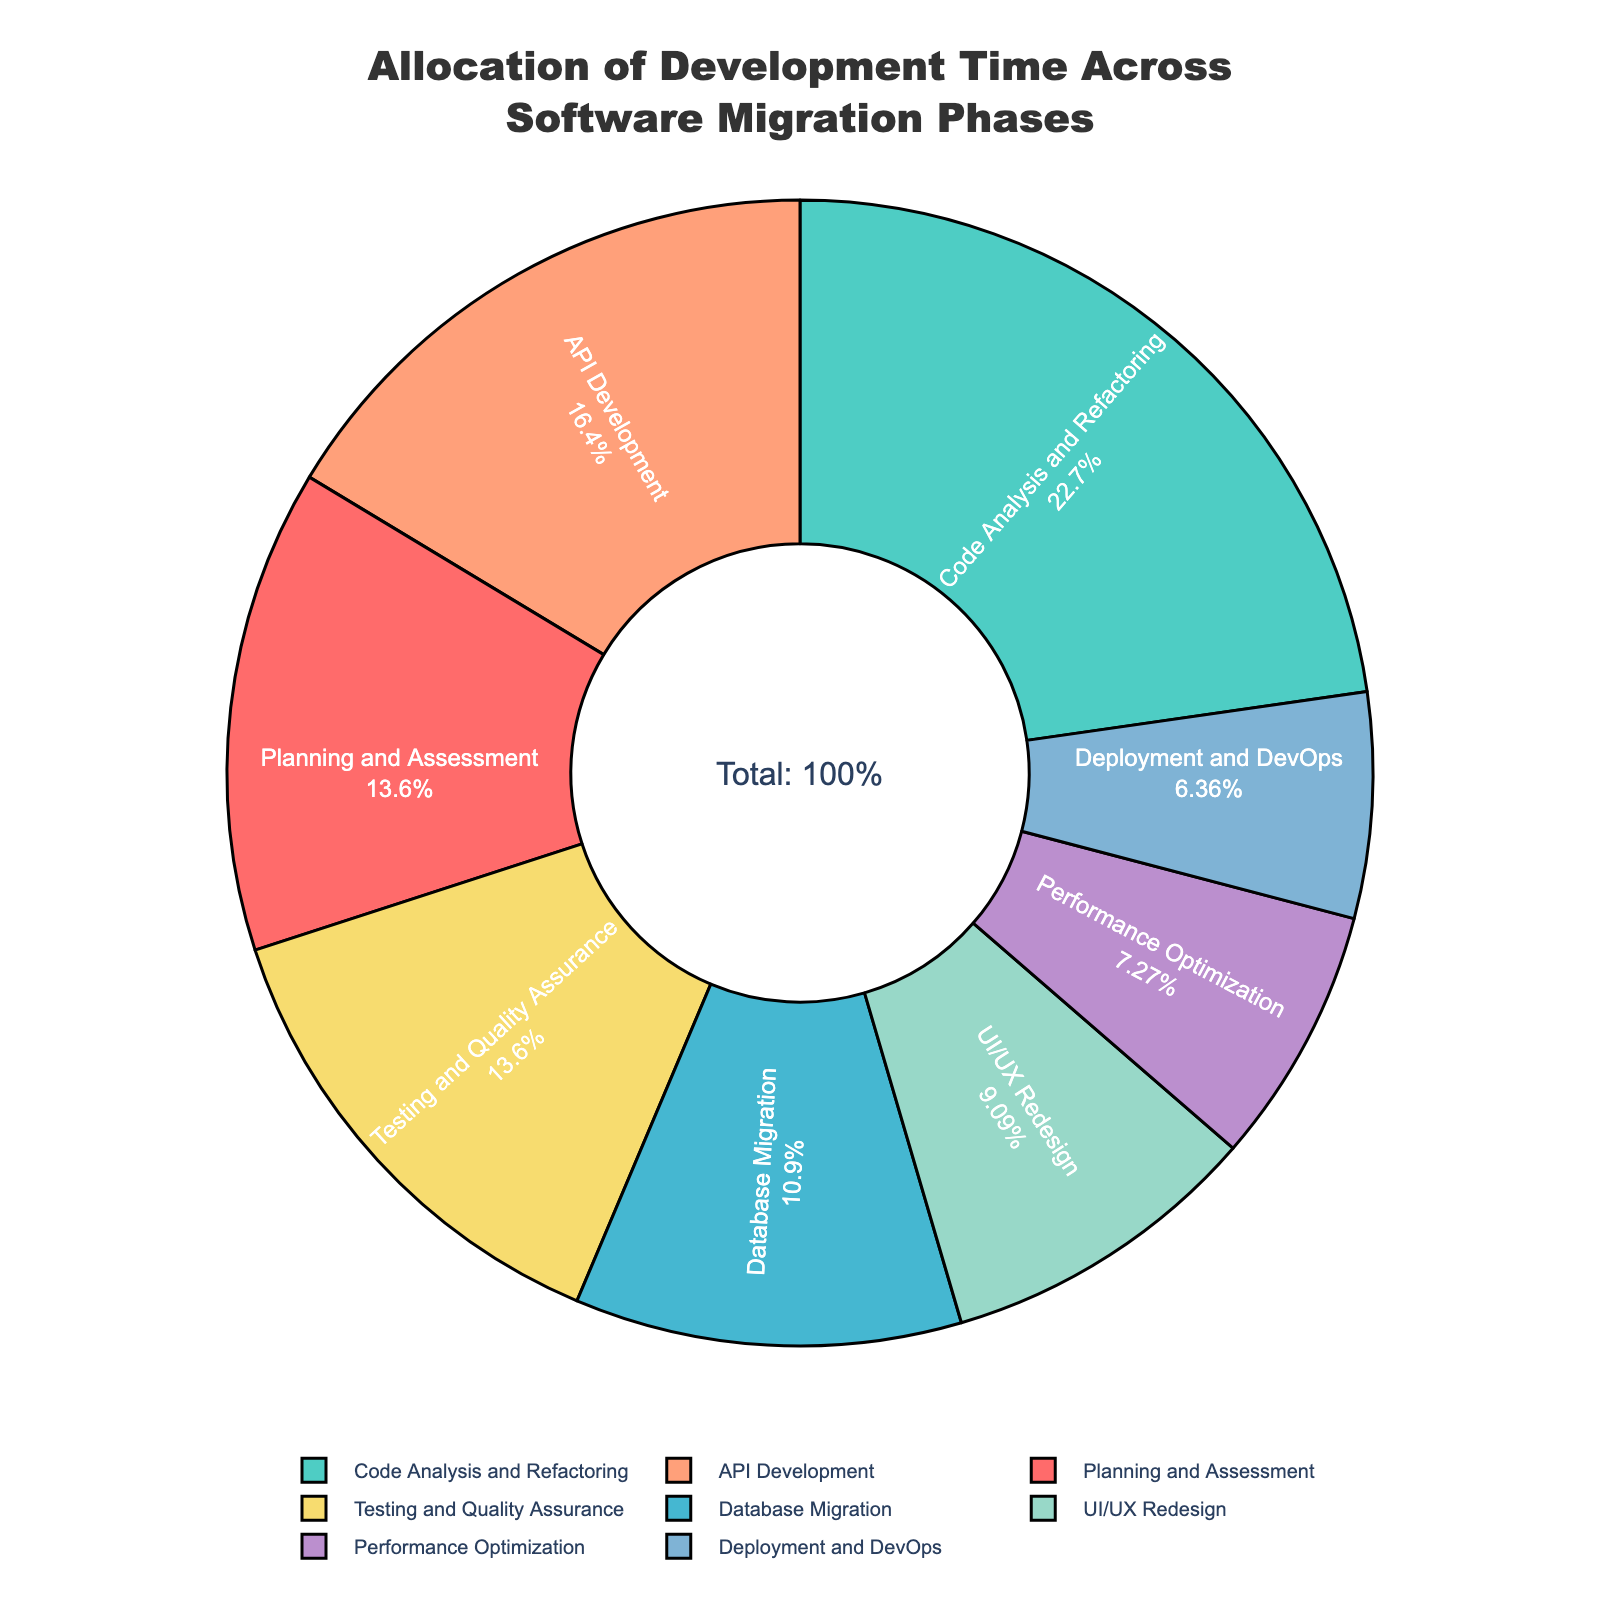What percentage of the total development time is spent on both Testing and Quality Assurance and Performance Optimization combined? To find the combined percentage spent on Testing and Quality Assurance and Performance Optimization, refer to the figure: Testing and Quality Assurance is 15%, and Performance Optimization is 8%. Adding these together, 15% + 8% = 23%.
Answer: 23% Which phase has the highest allocation of development time, and what is its percentage? Look at the slices of the pie chart and identify the one with the largest area to determine the phase with the highest allocation: Code Analysis and Refactoring has the pie slice representing 25%.
Answer: Code Analysis and Refactoring, 25% Does the time allocated to UI/UX Redesign exceed the time allocated to Deployment and DevOps? Check the percentages for UI/UX Redesign and Deployment and DevOps: UI/UX Redesign has 10%, while Deployment and DevOps have 7%. Since 10% is greater than 7%, UI/UX Redesign exceeds Deployment and DevOps.
Answer: Yes By how much (%) does the time allocated to API Development exceed the time allocated to Database Migration? Look at the percentages for both API Development and Database Migration: API Development is 18%, and Database Migration is 12%. Subtract the latter from the former to find the difference: 18% - 12% = 6%.
Answer: 6% What is the combined allocation for Planning and Assessment, and Deployment and DevOps? Add the percentages for Planning and Assessment (15%) and Deployment and DevOps (7%): 15% + 7% = 22%.
Answer: 22% Is the allocation for Code Analysis and Refactoring greater than the sum of UI/UX Redesign and Performance Optimization? Compare the percentage of Code Analysis and Refactoring (25%) with the sum of UI/UX Redesign (10%) and Performance Optimization (8%): 10% + 8% = 18%. Since 25% is greater than 18%, Code Analysis and Refactoring has a greater allocation.
Answer: Yes Which two phases have the smallest allocations, and what are their percentages? Identify the smallest slices in the pie chart: Deployment and DevOps at 7% and Performance Optimization at 8%.
Answer: Deployment and DevOps: 7%, Performance Optimization: 8% What is the difference in percentage between the least and most allocated phases? Identify the percentages of the least allocated phase (Deployment and DevOps at 7%) and the most allocated phase (Code Analysis and Refactoring at 25%). Subtract the least allocated from the most allocated: 25% - 7% = 18%.
Answer: 18% What is the percentage of total development time not accounted for by API Development, and Testing and Quality Assurance? Subtract the combined percentage of API Development (18%) and Testing and Quality Assurance (15%) from the total (100%): 100% - (18% + 15%) = 100% - 33% = 67%.
Answer: 67% How do the allocations of Planning and Assessment compare to Database Migration? Compare the percentages: Planning and Assessment is 15%, while Database Migration is 12%. Since 15% is greater than 12%, Planning and Assessment has a higher allocation.
Answer: Planning and Assessment is greater 